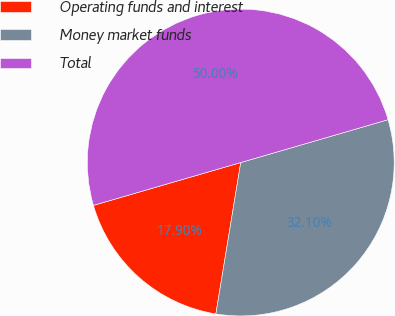Convert chart to OTSL. <chart><loc_0><loc_0><loc_500><loc_500><pie_chart><fcel>Operating funds and interest<fcel>Money market funds<fcel>Total<nl><fcel>17.9%<fcel>32.1%<fcel>50.0%<nl></chart> 